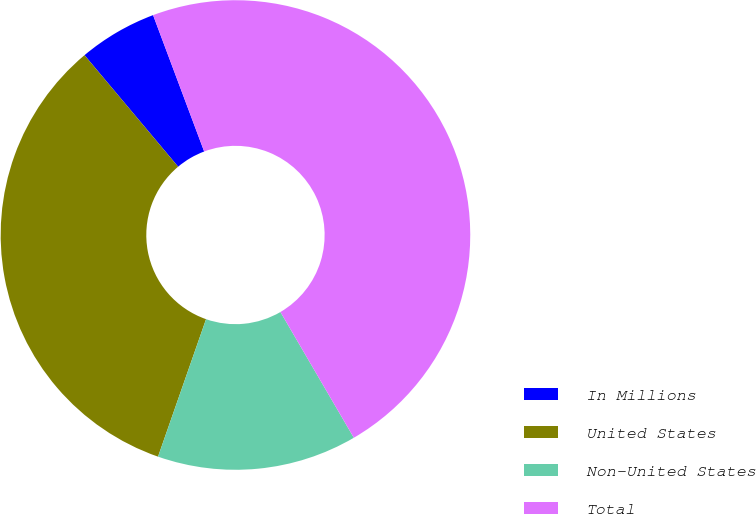Convert chart. <chart><loc_0><loc_0><loc_500><loc_500><pie_chart><fcel>In Millions<fcel>United States<fcel>Non-United States<fcel>Total<nl><fcel>5.41%<fcel>33.54%<fcel>13.76%<fcel>47.3%<nl></chart> 